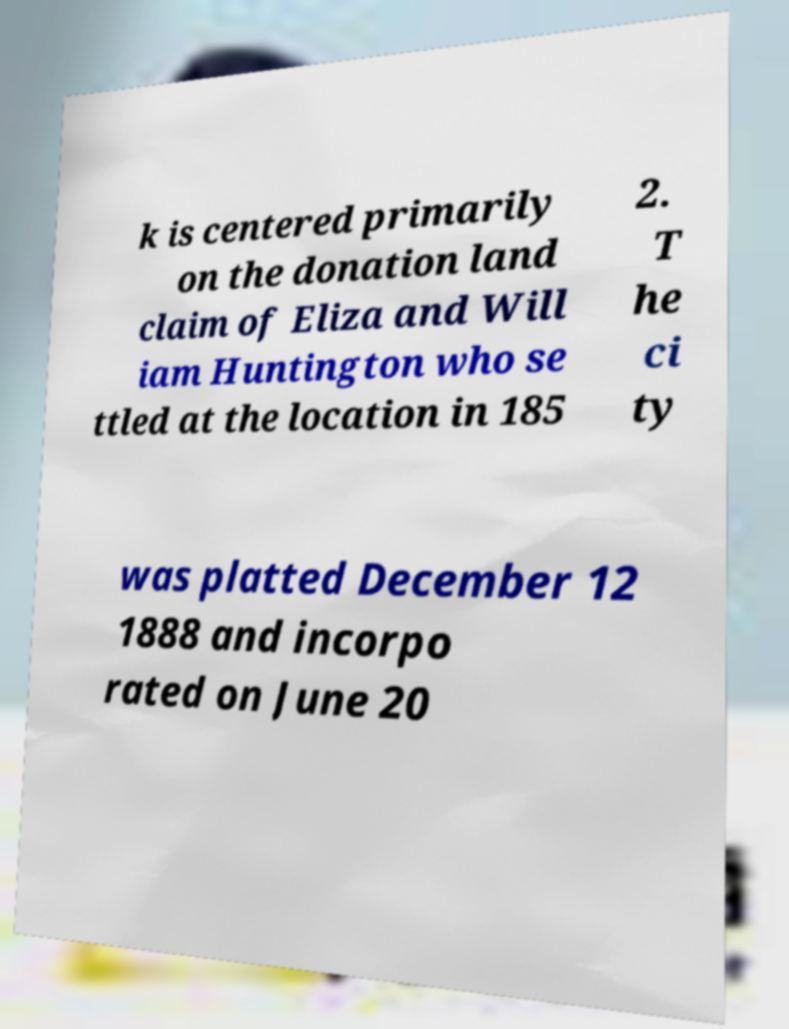There's text embedded in this image that I need extracted. Can you transcribe it verbatim? k is centered primarily on the donation land claim of Eliza and Will iam Huntington who se ttled at the location in 185 2. T he ci ty was platted December 12 1888 and incorpo rated on June 20 